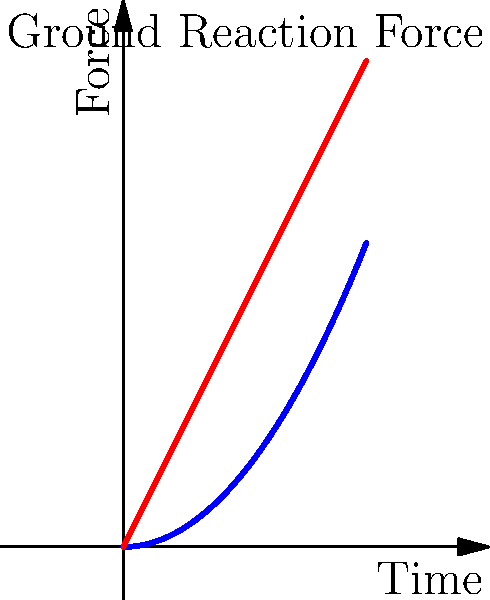Based on the graph showing ground reaction force patterns for heel strike and midfoot strike running, which running form is likely to be more efficient and potentially better for stress relief? To determine which running form is more efficient and better for stress relief, let's analyze the graph step-by-step:

1. The blue curve represents the heel strike running form, while the red curve represents the midfoot strike running form.

2. Heel strike pattern:
   - Shows a sharp initial peak in force (impact peak)
   - Followed by a gradual increase to a second peak (active peak)
   - The curve is more pronounced and has a steeper slope

3. Midfoot strike pattern:
   - Shows a single, smoother peak in force
   - The curve is more gradual and has a less steep slope

4. Efficiency in running is often associated with:
   - Reduced impact forces
   - Smoother force application
   - Less energy wasted in vertical oscillation

5. Stress relief in running is promoted by:
   - Reduced risk of injury
   - More natural movement patterns
   - Less jarring impact on joints

6. Comparing the two patterns:
   - The midfoot strike pattern shows lower initial impact forces
   - It has a smoother force application throughout the stride
   - The single peak suggests less vertical oscillation

7. These characteristics of the midfoot strike pattern indicate:
   - Potentially lower risk of injury
   - More efficient use of energy
   - Less stress on joints and muscles

Therefore, based on the graph and biomechanical principles, the midfoot strike running form is likely to be more efficient and potentially better for stress relief.
Answer: Midfoot strike 